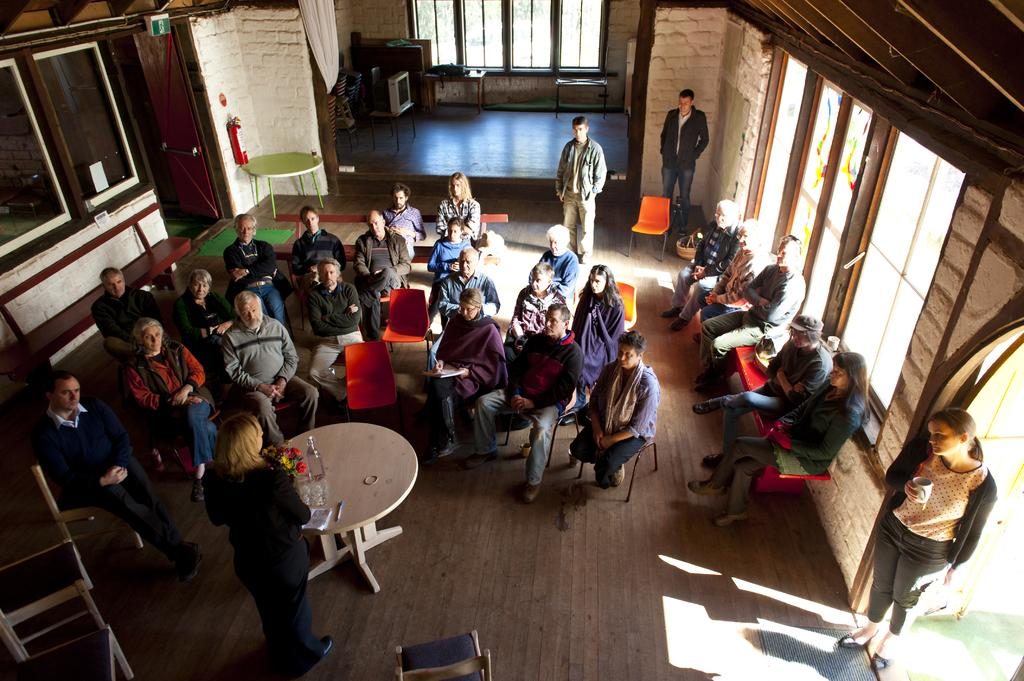What is the woman in the image wearing? The woman is wearing a black dress in the image. What is the woman doing in the image? The woman is standing in front of a group of people. What are the chairs like that the group of people is sitting on? The group of people is sitting on orange chairs. How many people are standing in the background of the image? There are three persons standing in the background of the image. What type of engine is visible in the image? There is no engine present in the image. What type of authority does the woman have over the group of people in the image? The image does not provide any information about the woman's authority over the group of people. 